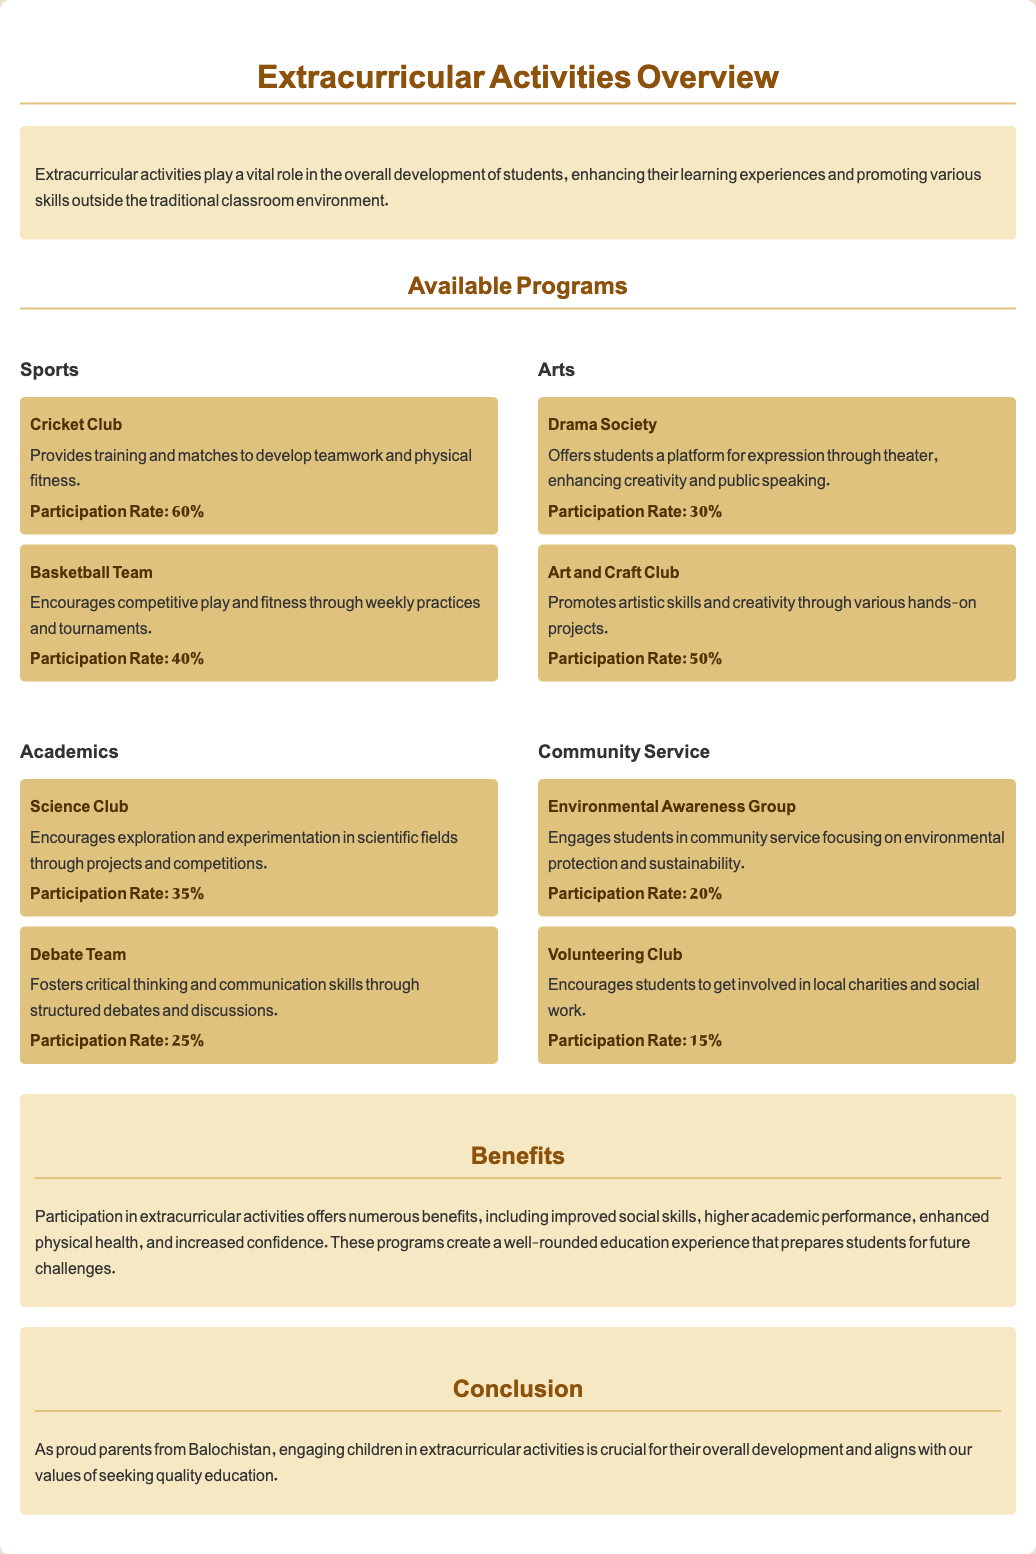What is the participation rate for the Cricket Club? The participation rate for the Cricket Club is detailed in the document, specifically noted as 60%.
Answer: 60% How many programs are listed under Sports? The document lists two programs under Sports, which are the Cricket Club and the Basketball Team.
Answer: 2 What is a benefit of participating in extracurricular activities mentioned in the document? The document states that participation in extracurricular activities offers numerous benefits, including improved social skills.
Answer: Improved social skills Which club focuses on artistic skills? The Art and Craft Club is specifically mentioned as promoting artistic skills and creativity.
Answer: Art and Craft Club What is the participation rate of the Debate Team? The participation rate of the Debate Team is specified in the document as 25%.
Answer: 25% What type of activities does the Environmental Awareness Group engage in? The Environmental Awareness Group is involved in community service focusing on environmental protection and sustainability.
Answer: Environmental protection and sustainability Which program has the lowest participation rate? Among the programs listed, the Volunteering Club has the lowest participation rate at 15%.
Answer: 15% What is the overall importance of extracurricular activities highlighted in the document? The document emphasizes that extracurricular activities are vital for overall student development beyond traditional classroom education.
Answer: Overall development 